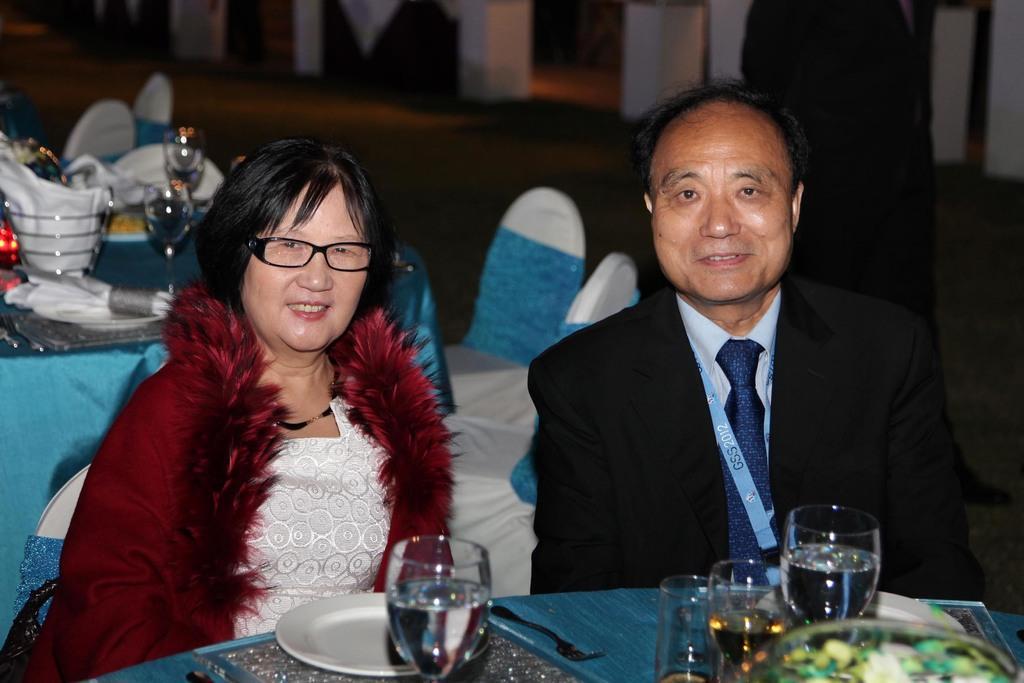Please provide a concise description of this image. In the image we can see a man and a woman wearing clothes and they are smiling. They are sitting on a chair, this is a neck chain and spectacles. In front of them there is a table. On the table we can see a plate, fork, glass and wine glasses. This is a floor and these are the tissue papers. 